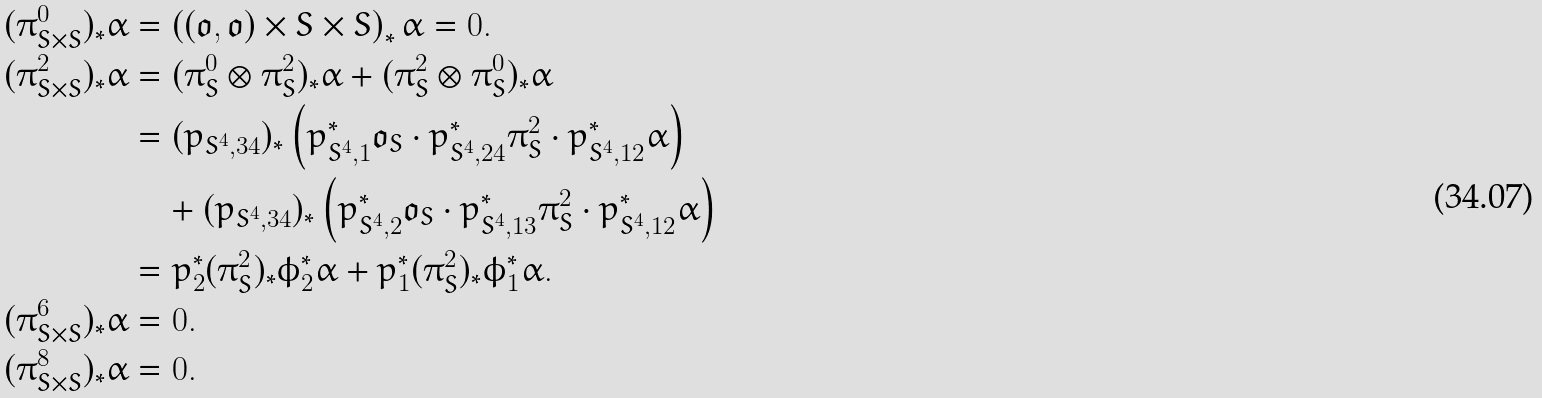<formula> <loc_0><loc_0><loc_500><loc_500>( \pi ^ { 0 } _ { S \times S } ) _ { * } \alpha & = \left ( ( \mathfrak { o } , \mathfrak { o } ) \times S \times S \right ) _ { * } \alpha = 0 . \\ ( \pi ^ { 2 } _ { S \times S } ) _ { * } \alpha & = ( \pi ^ { 0 } _ { S } \otimes \pi ^ { 2 } _ { S } ) _ { * } \alpha + ( \pi ^ { 2 } _ { S } \otimes \pi ^ { 0 } _ { S } ) _ { * } \alpha \\ & = ( p _ { S ^ { 4 } , 3 4 } ) _ { * } \left ( p _ { S ^ { 4 } , 1 } ^ { * } \mathfrak { o } _ { S } \cdot p _ { S ^ { 4 } , 2 4 } ^ { * } \pi ^ { 2 } _ { S } \cdot p _ { S ^ { 4 } , 1 2 } ^ { * } \alpha \right ) \\ & \quad + ( p _ { S ^ { 4 } , 3 4 } ) _ { * } \left ( p _ { S ^ { 4 } , 2 } ^ { * } \mathfrak { o } _ { S } \cdot p _ { S ^ { 4 } , 1 3 } ^ { * } \pi ^ { 2 } _ { S } \cdot p _ { S ^ { 4 } , 1 2 } ^ { * } \alpha \right ) \\ & = p _ { 2 } ^ { * } ( \pi ^ { 2 } _ { S } ) _ { * } \phi _ { 2 } ^ { * } \alpha + p _ { 1 } ^ { * } ( \pi ^ { 2 } _ { S } ) _ { * } \phi _ { 1 } ^ { * } \alpha . \\ ( \pi ^ { 6 } _ { S \times S } ) _ { * } \alpha & = 0 . \\ ( \pi ^ { 8 } _ { S \times S } ) _ { * } \alpha & = 0 .</formula> 